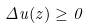<formula> <loc_0><loc_0><loc_500><loc_500>\Delta u ( z ) \geq 0</formula> 